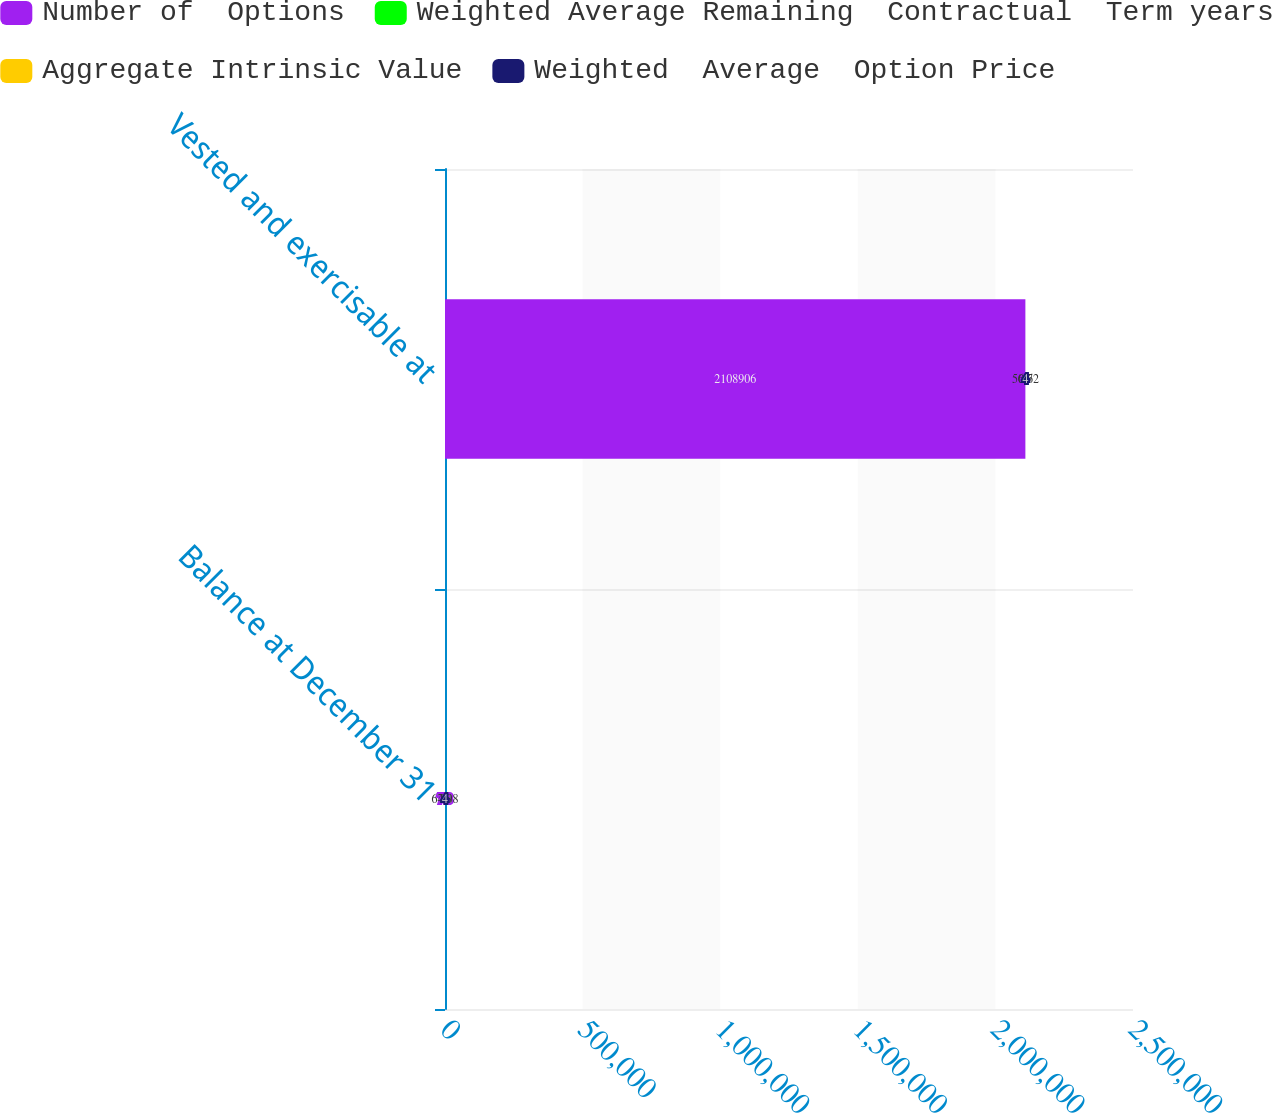Convert chart. <chart><loc_0><loc_0><loc_500><loc_500><stacked_bar_chart><ecel><fcel>Balance at December 31<fcel>Vested and exercisable at<nl><fcel>Number of  Options<fcel>7.8<fcel>2.10891e+06<nl><fcel>Weighted Average Remaining  Contractual  Term years<fcel>64.98<fcel>50.72<nl><fcel>Aggregate Intrinsic Value<fcel>7.8<fcel>6.6<nl><fcel>Weighted  Average  Option Price<fcel>4<fcel>4<nl></chart> 